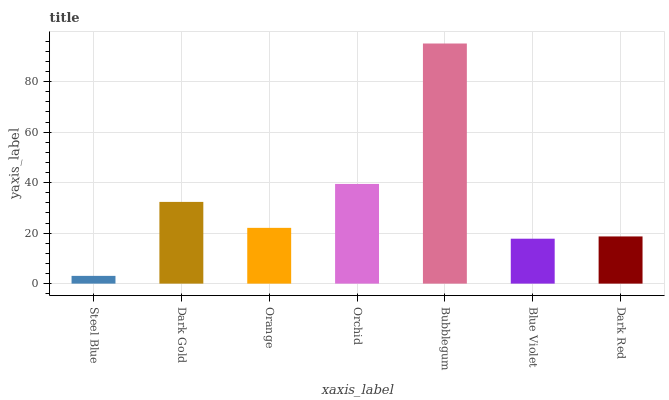Is Dark Gold the minimum?
Answer yes or no. No. Is Dark Gold the maximum?
Answer yes or no. No. Is Dark Gold greater than Steel Blue?
Answer yes or no. Yes. Is Steel Blue less than Dark Gold?
Answer yes or no. Yes. Is Steel Blue greater than Dark Gold?
Answer yes or no. No. Is Dark Gold less than Steel Blue?
Answer yes or no. No. Is Orange the high median?
Answer yes or no. Yes. Is Orange the low median?
Answer yes or no. Yes. Is Dark Gold the high median?
Answer yes or no. No. Is Blue Violet the low median?
Answer yes or no. No. 